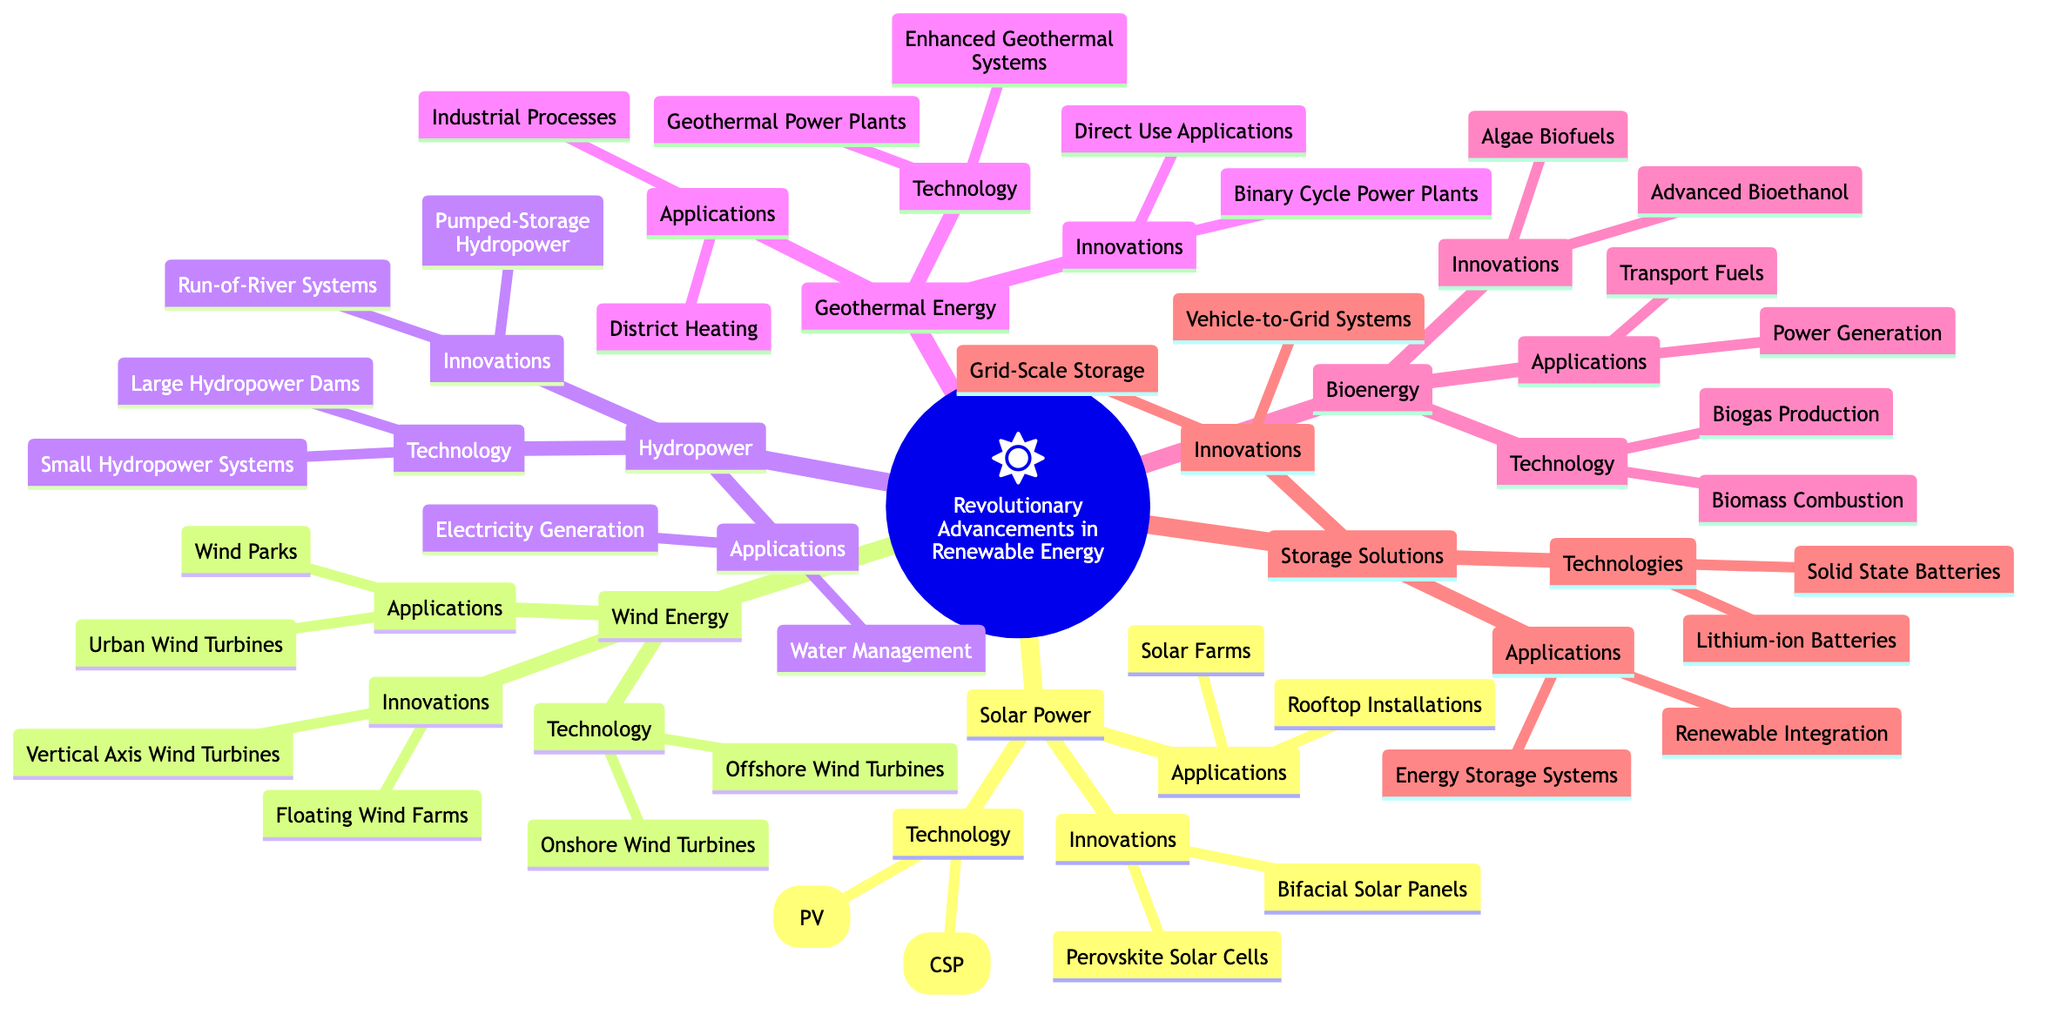What are the two main technologies under Solar Power? The diagram shows that the technologies listed under Solar Power are Photovoltaics (PV) and Concentrated Solar Power (CSP).
Answer: Photovoltaics (PV), Concentrated Solar Power (CSP) How many innovations are listed under Wind Energy? The diagram indicates that there are two innovations listed under Wind Energy: Floating Wind Farms and Vertical Axis Wind Turbines.
Answer: 2 What do the applications of Geothermal Energy focus on primarily? The diagram presents the applications of Geothermal Energy, which are District Heating and Industrial Processes, focusing primarily on warmth and industrial use.
Answer: District Heating, Industrial Processes Which type of storage technology is mentioned as a grid-scale solution? The Storage Solutions section of the diagram lists "Grid-Scale Storage" as one of the innovations, indicating it plays a crucial role in large-scale energy management.
Answer: Grid-Scale Storage What is one innovative application of Bioenergy? According to the diagram, one of the innovations under Bioenergy is Algae Biofuels, which suggests it represents a new approach to producing biofuels.
Answer: Algae Biofuels Which renewable energy source has both onshore and offshore technologies? The diagram clearly states Wind Energy as having two technologies: Onshore Wind Turbines and Offshore Wind Turbines, identifying it as a dual-source approach.
Answer: Wind Energy Which application category links Storage Solutions to Renewable Integration? The diagram illustrates that "Renewable Integration" is listed as an application under Storage Solutions, indicating how storage technologies assist in combining various energy types.
Answer: Renewable Integration How many different renewable energy sources are covered in the mind map? From the diagram, it can be observed that there are six main sources highlighted: Solar Power, Wind Energy, Hydropower, Geothermal Energy, Bioenergy, and Storage Solutions.
Answer: 6 What innovative system is associated with Hydropower? The innovations listed under Hydropower include Pumped-Storage Hydropower, demonstrating advancement in energy management for large water systems.
Answer: Pumped-Storage Hydropower 